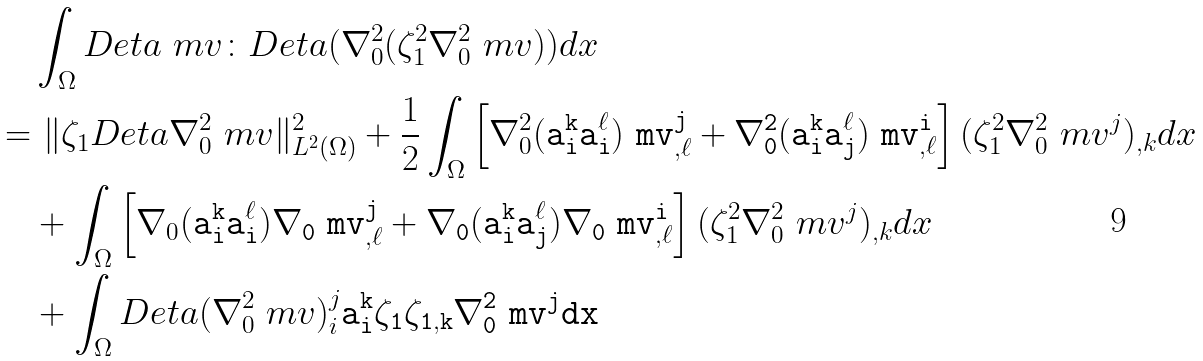<formula> <loc_0><loc_0><loc_500><loc_500>& \int _ { \Omega } D _ { \tt } e t a \ m v \colon D _ { \tt } e t a ( \nabla _ { 0 } ^ { 2 } ( \zeta _ { 1 } ^ { 2 } \nabla _ { 0 } ^ { 2 } \ m v ) ) d x \\ = & \ \| \zeta _ { 1 } D _ { \tt } e t a \nabla _ { 0 } ^ { 2 } \ m v \| ^ { 2 } _ { L ^ { 2 } ( \Omega ) } + \frac { 1 } { 2 } \int _ { \Omega } \left [ \nabla _ { 0 } ^ { 2 } ( \tt a _ { i } ^ { k } \tt a _ { i } ^ { \ell } ) \ m v _ { , \ell } ^ { j } + \nabla _ { 0 } ^ { 2 } ( \tt a _ { i } ^ { k } \tt a _ { j } ^ { \ell } ) \ m v _ { , \ell } ^ { i } \right ] ( \zeta _ { 1 } ^ { 2 } \nabla _ { 0 } ^ { 2 } \ m v ^ { j } ) _ { , k } d x \\ & + \int _ { \Omega } \left [ \nabla _ { 0 } ( \tt a _ { i } ^ { k } \tt a _ { i } ^ { \ell } ) \nabla _ { 0 } \ m v _ { , \ell } ^ { j } + \nabla _ { 0 } ( \tt a _ { i } ^ { k } \tt a _ { j } ^ { \ell } ) \nabla _ { 0 } \ m v _ { , \ell } ^ { i } \right ] ( \zeta _ { 1 } ^ { 2 } \nabla _ { 0 } ^ { 2 } \ m v ^ { j } ) _ { , k } d x \\ & + \int _ { \Omega } D _ { \tt } e t a ( \nabla _ { 0 } ^ { 2 } \ m v ) _ { i } ^ { j } \tt a _ { i } ^ { k } \zeta _ { 1 } \zeta _ { 1 , k } \nabla _ { 0 } ^ { 2 } \ m v ^ { j } d x</formula> 